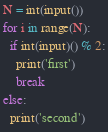<code> <loc_0><loc_0><loc_500><loc_500><_Python_>N = int(input())
for i in range(N):
  if int(input)() % 2:
    print('first')
    break
else:
  print('second')</code> 